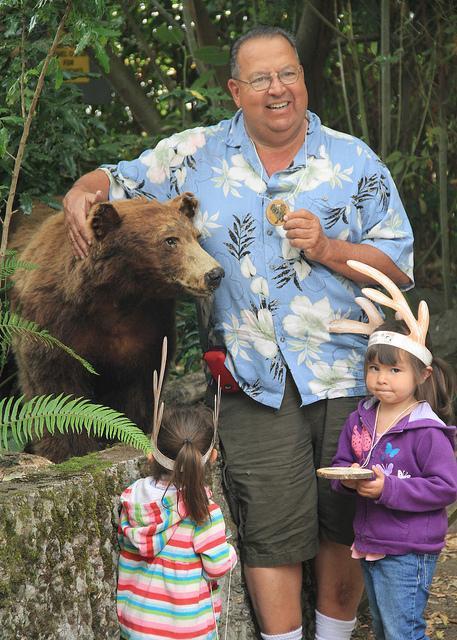How many people are there?
Give a very brief answer. 3. How many blue truck cabs are there?
Give a very brief answer. 0. 